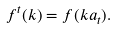Convert formula to latex. <formula><loc_0><loc_0><loc_500><loc_500>f ^ { t } ( k ) = f ( k a _ { t } ) .</formula> 